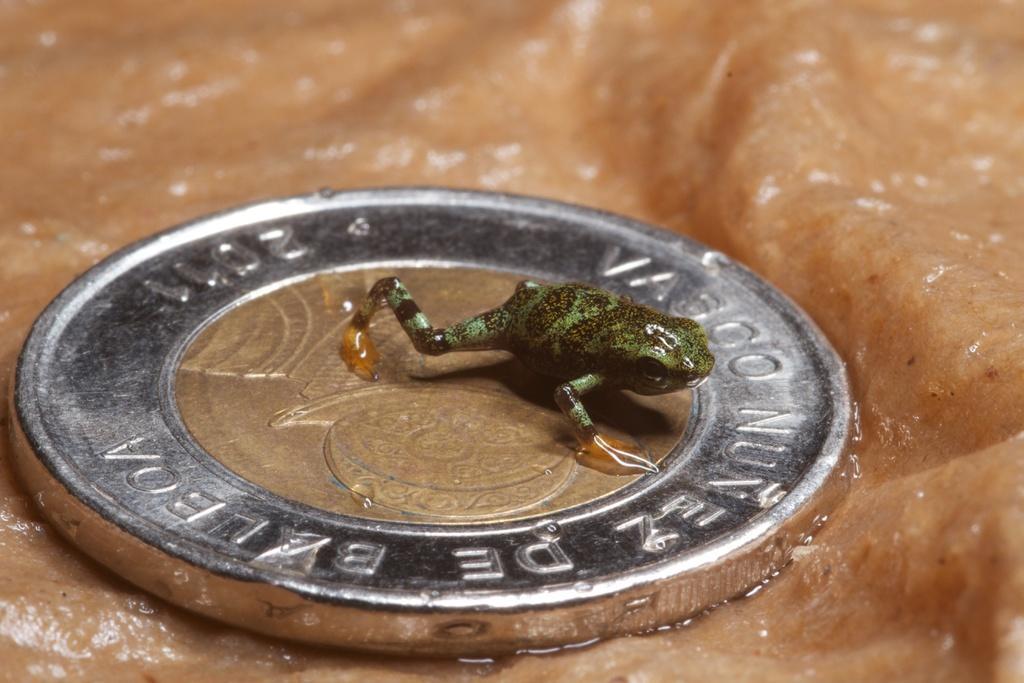Can you describe this image briefly? In this image we can see a coin on the surface on top of which there is a depiction of frog. 